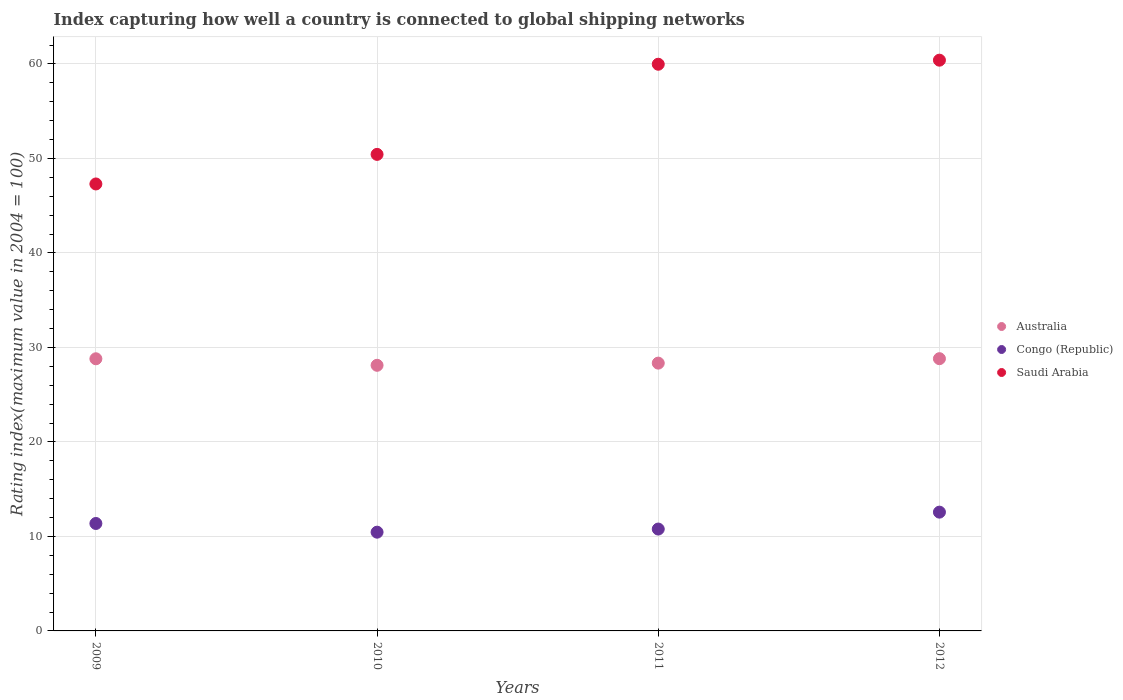How many different coloured dotlines are there?
Provide a succinct answer. 3. What is the rating index in Australia in 2012?
Keep it short and to the point. 28.81. Across all years, what is the maximum rating index in Saudi Arabia?
Your answer should be very brief. 60.4. Across all years, what is the minimum rating index in Australia?
Ensure brevity in your answer.  28.11. What is the total rating index in Saudi Arabia in the graph?
Provide a short and direct response. 218.1. What is the difference between the rating index in Saudi Arabia in 2010 and that in 2012?
Your response must be concise. -9.97. What is the difference between the rating index in Australia in 2011 and the rating index in Saudi Arabia in 2012?
Ensure brevity in your answer.  -32.06. What is the average rating index in Congo (Republic) per year?
Your answer should be compact. 11.29. In the year 2011, what is the difference between the rating index in Congo (Republic) and rating index in Australia?
Provide a short and direct response. -17.56. What is the ratio of the rating index in Congo (Republic) in 2011 to that in 2012?
Ensure brevity in your answer.  0.86. Is the rating index in Australia in 2009 less than that in 2010?
Your answer should be very brief. No. What is the difference between the highest and the second highest rating index in Congo (Republic)?
Your answer should be very brief. 1.2. What is the difference between the highest and the lowest rating index in Saudi Arabia?
Keep it short and to the point. 13.1. Is the rating index in Australia strictly less than the rating index in Congo (Republic) over the years?
Give a very brief answer. No. How many dotlines are there?
Provide a succinct answer. 3. What is the difference between two consecutive major ticks on the Y-axis?
Offer a terse response. 10. Are the values on the major ticks of Y-axis written in scientific E-notation?
Provide a succinct answer. No. How are the legend labels stacked?
Your answer should be compact. Vertical. What is the title of the graph?
Offer a very short reply. Index capturing how well a country is connected to global shipping networks. What is the label or title of the Y-axis?
Keep it short and to the point. Rating index(maximum value in 2004 = 100). What is the Rating index(maximum value in 2004 = 100) of Australia in 2009?
Your answer should be very brief. 28.8. What is the Rating index(maximum value in 2004 = 100) of Congo (Republic) in 2009?
Your answer should be very brief. 11.37. What is the Rating index(maximum value in 2004 = 100) in Saudi Arabia in 2009?
Your answer should be compact. 47.3. What is the Rating index(maximum value in 2004 = 100) in Australia in 2010?
Provide a short and direct response. 28.11. What is the Rating index(maximum value in 2004 = 100) in Congo (Republic) in 2010?
Keep it short and to the point. 10.45. What is the Rating index(maximum value in 2004 = 100) of Saudi Arabia in 2010?
Give a very brief answer. 50.43. What is the Rating index(maximum value in 2004 = 100) in Australia in 2011?
Provide a succinct answer. 28.34. What is the Rating index(maximum value in 2004 = 100) in Congo (Republic) in 2011?
Offer a terse response. 10.78. What is the Rating index(maximum value in 2004 = 100) in Saudi Arabia in 2011?
Your answer should be compact. 59.97. What is the Rating index(maximum value in 2004 = 100) of Australia in 2012?
Offer a very short reply. 28.81. What is the Rating index(maximum value in 2004 = 100) of Congo (Republic) in 2012?
Make the answer very short. 12.57. What is the Rating index(maximum value in 2004 = 100) in Saudi Arabia in 2012?
Make the answer very short. 60.4. Across all years, what is the maximum Rating index(maximum value in 2004 = 100) in Australia?
Offer a terse response. 28.81. Across all years, what is the maximum Rating index(maximum value in 2004 = 100) of Congo (Republic)?
Your answer should be very brief. 12.57. Across all years, what is the maximum Rating index(maximum value in 2004 = 100) in Saudi Arabia?
Provide a short and direct response. 60.4. Across all years, what is the minimum Rating index(maximum value in 2004 = 100) in Australia?
Keep it short and to the point. 28.11. Across all years, what is the minimum Rating index(maximum value in 2004 = 100) in Congo (Republic)?
Provide a succinct answer. 10.45. Across all years, what is the minimum Rating index(maximum value in 2004 = 100) of Saudi Arabia?
Ensure brevity in your answer.  47.3. What is the total Rating index(maximum value in 2004 = 100) in Australia in the graph?
Your answer should be very brief. 114.06. What is the total Rating index(maximum value in 2004 = 100) of Congo (Republic) in the graph?
Make the answer very short. 45.17. What is the total Rating index(maximum value in 2004 = 100) in Saudi Arabia in the graph?
Make the answer very short. 218.1. What is the difference between the Rating index(maximum value in 2004 = 100) of Australia in 2009 and that in 2010?
Your answer should be very brief. 0.69. What is the difference between the Rating index(maximum value in 2004 = 100) of Saudi Arabia in 2009 and that in 2010?
Ensure brevity in your answer.  -3.13. What is the difference between the Rating index(maximum value in 2004 = 100) of Australia in 2009 and that in 2011?
Your answer should be compact. 0.46. What is the difference between the Rating index(maximum value in 2004 = 100) in Congo (Republic) in 2009 and that in 2011?
Give a very brief answer. 0.59. What is the difference between the Rating index(maximum value in 2004 = 100) in Saudi Arabia in 2009 and that in 2011?
Provide a short and direct response. -12.67. What is the difference between the Rating index(maximum value in 2004 = 100) of Australia in 2009 and that in 2012?
Ensure brevity in your answer.  -0.01. What is the difference between the Rating index(maximum value in 2004 = 100) of Australia in 2010 and that in 2011?
Your response must be concise. -0.23. What is the difference between the Rating index(maximum value in 2004 = 100) of Congo (Republic) in 2010 and that in 2011?
Offer a very short reply. -0.33. What is the difference between the Rating index(maximum value in 2004 = 100) in Saudi Arabia in 2010 and that in 2011?
Provide a short and direct response. -9.54. What is the difference between the Rating index(maximum value in 2004 = 100) in Australia in 2010 and that in 2012?
Make the answer very short. -0.7. What is the difference between the Rating index(maximum value in 2004 = 100) in Congo (Republic) in 2010 and that in 2012?
Your answer should be compact. -2.12. What is the difference between the Rating index(maximum value in 2004 = 100) of Saudi Arabia in 2010 and that in 2012?
Give a very brief answer. -9.97. What is the difference between the Rating index(maximum value in 2004 = 100) in Australia in 2011 and that in 2012?
Keep it short and to the point. -0.47. What is the difference between the Rating index(maximum value in 2004 = 100) in Congo (Republic) in 2011 and that in 2012?
Offer a terse response. -1.79. What is the difference between the Rating index(maximum value in 2004 = 100) of Saudi Arabia in 2011 and that in 2012?
Offer a terse response. -0.43. What is the difference between the Rating index(maximum value in 2004 = 100) of Australia in 2009 and the Rating index(maximum value in 2004 = 100) of Congo (Republic) in 2010?
Give a very brief answer. 18.35. What is the difference between the Rating index(maximum value in 2004 = 100) in Australia in 2009 and the Rating index(maximum value in 2004 = 100) in Saudi Arabia in 2010?
Give a very brief answer. -21.63. What is the difference between the Rating index(maximum value in 2004 = 100) of Congo (Republic) in 2009 and the Rating index(maximum value in 2004 = 100) of Saudi Arabia in 2010?
Make the answer very short. -39.06. What is the difference between the Rating index(maximum value in 2004 = 100) of Australia in 2009 and the Rating index(maximum value in 2004 = 100) of Congo (Republic) in 2011?
Make the answer very short. 18.02. What is the difference between the Rating index(maximum value in 2004 = 100) of Australia in 2009 and the Rating index(maximum value in 2004 = 100) of Saudi Arabia in 2011?
Your answer should be very brief. -31.17. What is the difference between the Rating index(maximum value in 2004 = 100) of Congo (Republic) in 2009 and the Rating index(maximum value in 2004 = 100) of Saudi Arabia in 2011?
Give a very brief answer. -48.6. What is the difference between the Rating index(maximum value in 2004 = 100) of Australia in 2009 and the Rating index(maximum value in 2004 = 100) of Congo (Republic) in 2012?
Offer a terse response. 16.23. What is the difference between the Rating index(maximum value in 2004 = 100) in Australia in 2009 and the Rating index(maximum value in 2004 = 100) in Saudi Arabia in 2012?
Make the answer very short. -31.6. What is the difference between the Rating index(maximum value in 2004 = 100) of Congo (Republic) in 2009 and the Rating index(maximum value in 2004 = 100) of Saudi Arabia in 2012?
Provide a succinct answer. -49.03. What is the difference between the Rating index(maximum value in 2004 = 100) in Australia in 2010 and the Rating index(maximum value in 2004 = 100) in Congo (Republic) in 2011?
Offer a terse response. 17.33. What is the difference between the Rating index(maximum value in 2004 = 100) of Australia in 2010 and the Rating index(maximum value in 2004 = 100) of Saudi Arabia in 2011?
Keep it short and to the point. -31.86. What is the difference between the Rating index(maximum value in 2004 = 100) in Congo (Republic) in 2010 and the Rating index(maximum value in 2004 = 100) in Saudi Arabia in 2011?
Offer a terse response. -49.52. What is the difference between the Rating index(maximum value in 2004 = 100) of Australia in 2010 and the Rating index(maximum value in 2004 = 100) of Congo (Republic) in 2012?
Your answer should be very brief. 15.54. What is the difference between the Rating index(maximum value in 2004 = 100) in Australia in 2010 and the Rating index(maximum value in 2004 = 100) in Saudi Arabia in 2012?
Offer a terse response. -32.29. What is the difference between the Rating index(maximum value in 2004 = 100) of Congo (Republic) in 2010 and the Rating index(maximum value in 2004 = 100) of Saudi Arabia in 2012?
Keep it short and to the point. -49.95. What is the difference between the Rating index(maximum value in 2004 = 100) in Australia in 2011 and the Rating index(maximum value in 2004 = 100) in Congo (Republic) in 2012?
Your response must be concise. 15.77. What is the difference between the Rating index(maximum value in 2004 = 100) in Australia in 2011 and the Rating index(maximum value in 2004 = 100) in Saudi Arabia in 2012?
Ensure brevity in your answer.  -32.06. What is the difference between the Rating index(maximum value in 2004 = 100) in Congo (Republic) in 2011 and the Rating index(maximum value in 2004 = 100) in Saudi Arabia in 2012?
Make the answer very short. -49.62. What is the average Rating index(maximum value in 2004 = 100) in Australia per year?
Offer a terse response. 28.52. What is the average Rating index(maximum value in 2004 = 100) in Congo (Republic) per year?
Keep it short and to the point. 11.29. What is the average Rating index(maximum value in 2004 = 100) of Saudi Arabia per year?
Your response must be concise. 54.52. In the year 2009, what is the difference between the Rating index(maximum value in 2004 = 100) of Australia and Rating index(maximum value in 2004 = 100) of Congo (Republic)?
Offer a terse response. 17.43. In the year 2009, what is the difference between the Rating index(maximum value in 2004 = 100) of Australia and Rating index(maximum value in 2004 = 100) of Saudi Arabia?
Provide a succinct answer. -18.5. In the year 2009, what is the difference between the Rating index(maximum value in 2004 = 100) in Congo (Republic) and Rating index(maximum value in 2004 = 100) in Saudi Arabia?
Offer a very short reply. -35.93. In the year 2010, what is the difference between the Rating index(maximum value in 2004 = 100) of Australia and Rating index(maximum value in 2004 = 100) of Congo (Republic)?
Ensure brevity in your answer.  17.66. In the year 2010, what is the difference between the Rating index(maximum value in 2004 = 100) in Australia and Rating index(maximum value in 2004 = 100) in Saudi Arabia?
Provide a succinct answer. -22.32. In the year 2010, what is the difference between the Rating index(maximum value in 2004 = 100) in Congo (Republic) and Rating index(maximum value in 2004 = 100) in Saudi Arabia?
Offer a very short reply. -39.98. In the year 2011, what is the difference between the Rating index(maximum value in 2004 = 100) in Australia and Rating index(maximum value in 2004 = 100) in Congo (Republic)?
Ensure brevity in your answer.  17.56. In the year 2011, what is the difference between the Rating index(maximum value in 2004 = 100) of Australia and Rating index(maximum value in 2004 = 100) of Saudi Arabia?
Provide a short and direct response. -31.63. In the year 2011, what is the difference between the Rating index(maximum value in 2004 = 100) of Congo (Republic) and Rating index(maximum value in 2004 = 100) of Saudi Arabia?
Keep it short and to the point. -49.19. In the year 2012, what is the difference between the Rating index(maximum value in 2004 = 100) in Australia and Rating index(maximum value in 2004 = 100) in Congo (Republic)?
Provide a short and direct response. 16.24. In the year 2012, what is the difference between the Rating index(maximum value in 2004 = 100) in Australia and Rating index(maximum value in 2004 = 100) in Saudi Arabia?
Your response must be concise. -31.59. In the year 2012, what is the difference between the Rating index(maximum value in 2004 = 100) in Congo (Republic) and Rating index(maximum value in 2004 = 100) in Saudi Arabia?
Ensure brevity in your answer.  -47.83. What is the ratio of the Rating index(maximum value in 2004 = 100) of Australia in 2009 to that in 2010?
Ensure brevity in your answer.  1.02. What is the ratio of the Rating index(maximum value in 2004 = 100) in Congo (Republic) in 2009 to that in 2010?
Your response must be concise. 1.09. What is the ratio of the Rating index(maximum value in 2004 = 100) in Saudi Arabia in 2009 to that in 2010?
Offer a very short reply. 0.94. What is the ratio of the Rating index(maximum value in 2004 = 100) in Australia in 2009 to that in 2011?
Your answer should be very brief. 1.02. What is the ratio of the Rating index(maximum value in 2004 = 100) in Congo (Republic) in 2009 to that in 2011?
Keep it short and to the point. 1.05. What is the ratio of the Rating index(maximum value in 2004 = 100) of Saudi Arabia in 2009 to that in 2011?
Your answer should be compact. 0.79. What is the ratio of the Rating index(maximum value in 2004 = 100) of Congo (Republic) in 2009 to that in 2012?
Provide a short and direct response. 0.9. What is the ratio of the Rating index(maximum value in 2004 = 100) in Saudi Arabia in 2009 to that in 2012?
Make the answer very short. 0.78. What is the ratio of the Rating index(maximum value in 2004 = 100) of Australia in 2010 to that in 2011?
Your answer should be very brief. 0.99. What is the ratio of the Rating index(maximum value in 2004 = 100) in Congo (Republic) in 2010 to that in 2011?
Give a very brief answer. 0.97. What is the ratio of the Rating index(maximum value in 2004 = 100) of Saudi Arabia in 2010 to that in 2011?
Keep it short and to the point. 0.84. What is the ratio of the Rating index(maximum value in 2004 = 100) in Australia in 2010 to that in 2012?
Ensure brevity in your answer.  0.98. What is the ratio of the Rating index(maximum value in 2004 = 100) of Congo (Republic) in 2010 to that in 2012?
Ensure brevity in your answer.  0.83. What is the ratio of the Rating index(maximum value in 2004 = 100) of Saudi Arabia in 2010 to that in 2012?
Your answer should be very brief. 0.83. What is the ratio of the Rating index(maximum value in 2004 = 100) of Australia in 2011 to that in 2012?
Make the answer very short. 0.98. What is the ratio of the Rating index(maximum value in 2004 = 100) of Congo (Republic) in 2011 to that in 2012?
Keep it short and to the point. 0.86. What is the difference between the highest and the second highest Rating index(maximum value in 2004 = 100) of Australia?
Your answer should be very brief. 0.01. What is the difference between the highest and the second highest Rating index(maximum value in 2004 = 100) in Saudi Arabia?
Provide a succinct answer. 0.43. What is the difference between the highest and the lowest Rating index(maximum value in 2004 = 100) of Australia?
Provide a short and direct response. 0.7. What is the difference between the highest and the lowest Rating index(maximum value in 2004 = 100) in Congo (Republic)?
Provide a short and direct response. 2.12. 